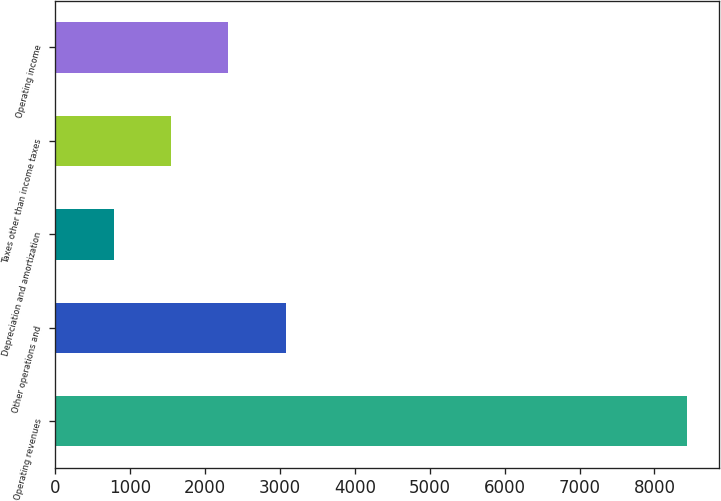Convert chart. <chart><loc_0><loc_0><loc_500><loc_500><bar_chart><fcel>Operating revenues<fcel>Other operations and<fcel>Depreciation and amortization<fcel>Taxes other than income taxes<fcel>Operating income<nl><fcel>8437<fcel>3077.8<fcel>781<fcel>1546.6<fcel>2312.2<nl></chart> 